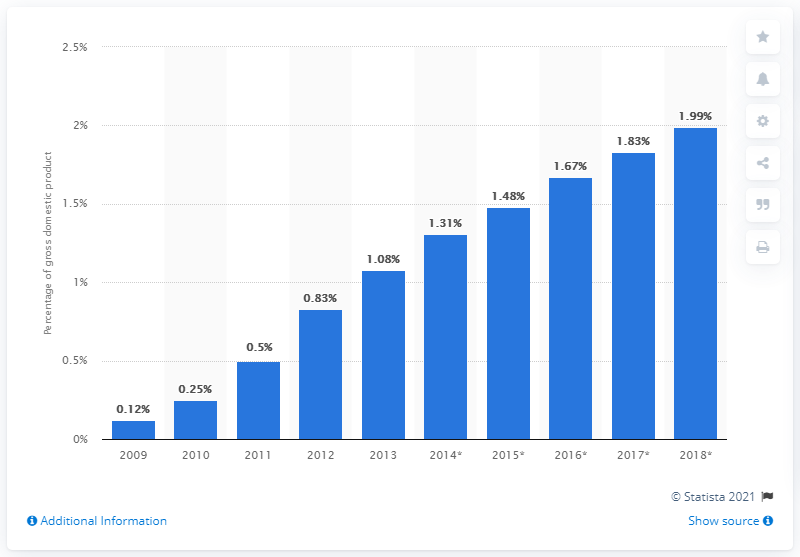Draw attention to some important aspects in this diagram. In 2013, B2C e-commerce accounted for approximately 1.08% of China's GDP. 